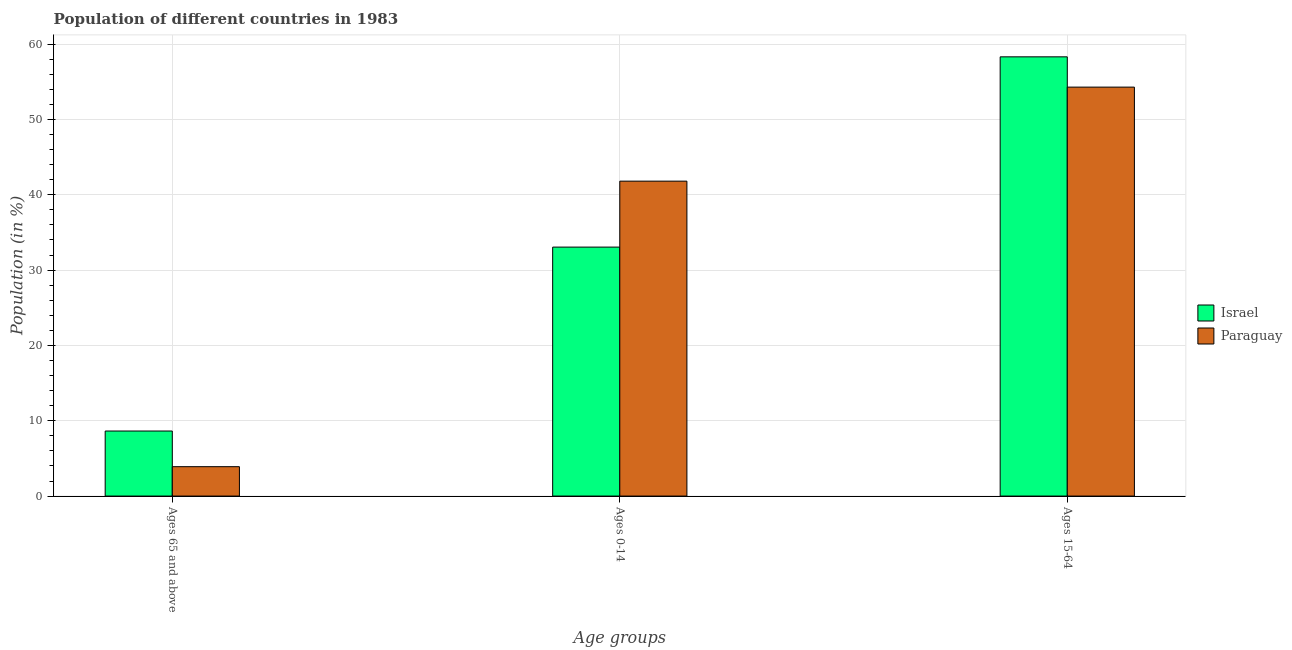How many groups of bars are there?
Keep it short and to the point. 3. Are the number of bars per tick equal to the number of legend labels?
Make the answer very short. Yes. How many bars are there on the 2nd tick from the left?
Your answer should be very brief. 2. What is the label of the 1st group of bars from the left?
Provide a succinct answer. Ages 65 and above. What is the percentage of population within the age-group of 65 and above in Paraguay?
Offer a very short reply. 3.9. Across all countries, what is the maximum percentage of population within the age-group 0-14?
Offer a terse response. 41.81. Across all countries, what is the minimum percentage of population within the age-group of 65 and above?
Provide a succinct answer. 3.9. In which country was the percentage of population within the age-group 0-14 maximum?
Give a very brief answer. Paraguay. In which country was the percentage of population within the age-group of 65 and above minimum?
Make the answer very short. Paraguay. What is the total percentage of population within the age-group of 65 and above in the graph?
Your response must be concise. 12.54. What is the difference between the percentage of population within the age-group 0-14 in Paraguay and that in Israel?
Offer a terse response. 8.76. What is the difference between the percentage of population within the age-group 0-14 in Israel and the percentage of population within the age-group 15-64 in Paraguay?
Make the answer very short. -21.24. What is the average percentage of population within the age-group 0-14 per country?
Your answer should be compact. 37.43. What is the difference between the percentage of population within the age-group of 65 and above and percentage of population within the age-group 0-14 in Paraguay?
Offer a very short reply. -37.91. What is the ratio of the percentage of population within the age-group of 65 and above in Paraguay to that in Israel?
Your response must be concise. 0.45. Is the percentage of population within the age-group 0-14 in Israel less than that in Paraguay?
Offer a terse response. Yes. Is the difference between the percentage of population within the age-group 0-14 in Israel and Paraguay greater than the difference between the percentage of population within the age-group of 65 and above in Israel and Paraguay?
Keep it short and to the point. No. What is the difference between the highest and the second highest percentage of population within the age-group 15-64?
Your answer should be compact. 4.02. What is the difference between the highest and the lowest percentage of population within the age-group of 65 and above?
Offer a very short reply. 4.74. In how many countries, is the percentage of population within the age-group of 65 and above greater than the average percentage of population within the age-group of 65 and above taken over all countries?
Give a very brief answer. 1. Is the sum of the percentage of population within the age-group 15-64 in Paraguay and Israel greater than the maximum percentage of population within the age-group of 65 and above across all countries?
Provide a short and direct response. Yes. What does the 1st bar from the left in Ages 65 and above represents?
Your response must be concise. Israel. Is it the case that in every country, the sum of the percentage of population within the age-group of 65 and above and percentage of population within the age-group 0-14 is greater than the percentage of population within the age-group 15-64?
Offer a terse response. No. Are all the bars in the graph horizontal?
Keep it short and to the point. No. How many countries are there in the graph?
Offer a terse response. 2. What is the difference between two consecutive major ticks on the Y-axis?
Keep it short and to the point. 10. Does the graph contain grids?
Ensure brevity in your answer.  Yes. Where does the legend appear in the graph?
Keep it short and to the point. Center right. How many legend labels are there?
Offer a very short reply. 2. What is the title of the graph?
Your response must be concise. Population of different countries in 1983. What is the label or title of the X-axis?
Your answer should be very brief. Age groups. What is the label or title of the Y-axis?
Your answer should be very brief. Population (in %). What is the Population (in %) of Israel in Ages 65 and above?
Your response must be concise. 8.64. What is the Population (in %) in Paraguay in Ages 65 and above?
Make the answer very short. 3.9. What is the Population (in %) of Israel in Ages 0-14?
Ensure brevity in your answer.  33.05. What is the Population (in %) of Paraguay in Ages 0-14?
Give a very brief answer. 41.81. What is the Population (in %) in Israel in Ages 15-64?
Your answer should be compact. 58.31. What is the Population (in %) in Paraguay in Ages 15-64?
Offer a terse response. 54.29. Across all Age groups, what is the maximum Population (in %) of Israel?
Your answer should be very brief. 58.31. Across all Age groups, what is the maximum Population (in %) in Paraguay?
Provide a succinct answer. 54.29. Across all Age groups, what is the minimum Population (in %) in Israel?
Provide a short and direct response. 8.64. Across all Age groups, what is the minimum Population (in %) in Paraguay?
Offer a very short reply. 3.9. What is the total Population (in %) in Israel in the graph?
Your answer should be very brief. 100. What is the difference between the Population (in %) in Israel in Ages 65 and above and that in Ages 0-14?
Make the answer very short. -24.42. What is the difference between the Population (in %) of Paraguay in Ages 65 and above and that in Ages 0-14?
Offer a very short reply. -37.91. What is the difference between the Population (in %) in Israel in Ages 65 and above and that in Ages 15-64?
Provide a succinct answer. -49.68. What is the difference between the Population (in %) of Paraguay in Ages 65 and above and that in Ages 15-64?
Your response must be concise. -50.39. What is the difference between the Population (in %) in Israel in Ages 0-14 and that in Ages 15-64?
Offer a very short reply. -25.26. What is the difference between the Population (in %) of Paraguay in Ages 0-14 and that in Ages 15-64?
Make the answer very short. -12.48. What is the difference between the Population (in %) of Israel in Ages 65 and above and the Population (in %) of Paraguay in Ages 0-14?
Offer a very short reply. -33.17. What is the difference between the Population (in %) in Israel in Ages 65 and above and the Population (in %) in Paraguay in Ages 15-64?
Ensure brevity in your answer.  -45.66. What is the difference between the Population (in %) of Israel in Ages 0-14 and the Population (in %) of Paraguay in Ages 15-64?
Your answer should be very brief. -21.24. What is the average Population (in %) of Israel per Age groups?
Offer a terse response. 33.33. What is the average Population (in %) of Paraguay per Age groups?
Provide a succinct answer. 33.33. What is the difference between the Population (in %) in Israel and Population (in %) in Paraguay in Ages 65 and above?
Provide a succinct answer. 4.74. What is the difference between the Population (in %) in Israel and Population (in %) in Paraguay in Ages 0-14?
Provide a succinct answer. -8.76. What is the difference between the Population (in %) of Israel and Population (in %) of Paraguay in Ages 15-64?
Offer a terse response. 4.02. What is the ratio of the Population (in %) of Israel in Ages 65 and above to that in Ages 0-14?
Keep it short and to the point. 0.26. What is the ratio of the Population (in %) of Paraguay in Ages 65 and above to that in Ages 0-14?
Your response must be concise. 0.09. What is the ratio of the Population (in %) of Israel in Ages 65 and above to that in Ages 15-64?
Make the answer very short. 0.15. What is the ratio of the Population (in %) of Paraguay in Ages 65 and above to that in Ages 15-64?
Keep it short and to the point. 0.07. What is the ratio of the Population (in %) of Israel in Ages 0-14 to that in Ages 15-64?
Your answer should be compact. 0.57. What is the ratio of the Population (in %) of Paraguay in Ages 0-14 to that in Ages 15-64?
Give a very brief answer. 0.77. What is the difference between the highest and the second highest Population (in %) in Israel?
Provide a succinct answer. 25.26. What is the difference between the highest and the second highest Population (in %) in Paraguay?
Give a very brief answer. 12.48. What is the difference between the highest and the lowest Population (in %) in Israel?
Your response must be concise. 49.68. What is the difference between the highest and the lowest Population (in %) in Paraguay?
Offer a terse response. 50.39. 